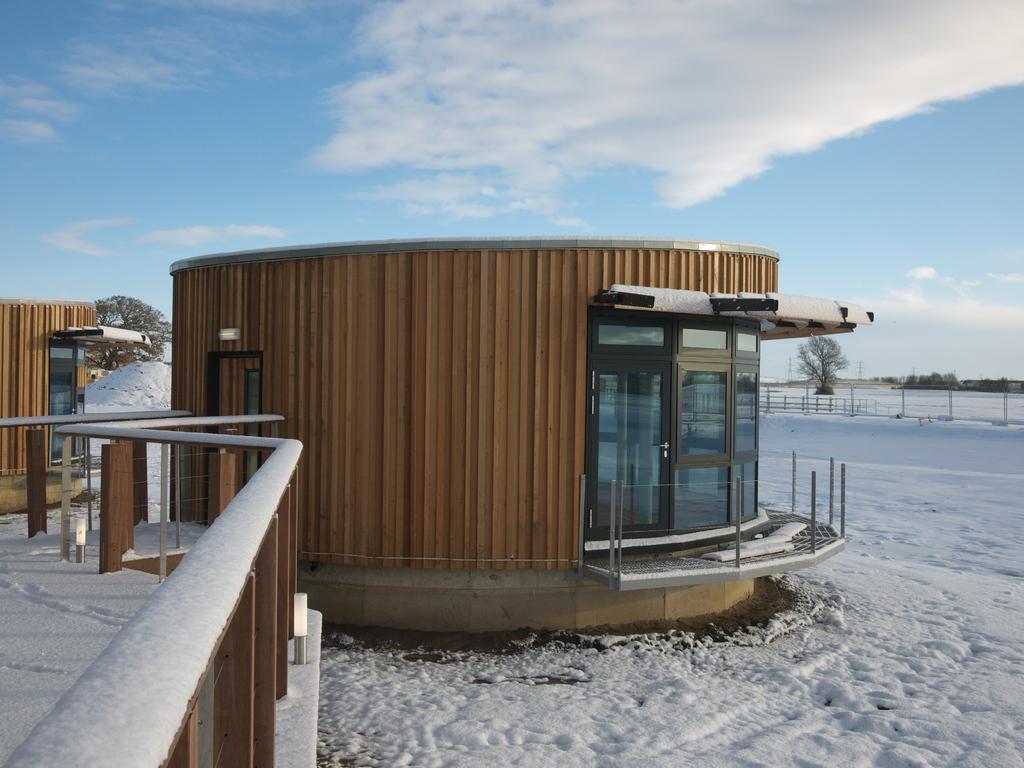How would you summarize this image in a sentence or two? In this image we can see a house, there are some poles, trees, fence, doors and snow, in the background we can see the sky. 